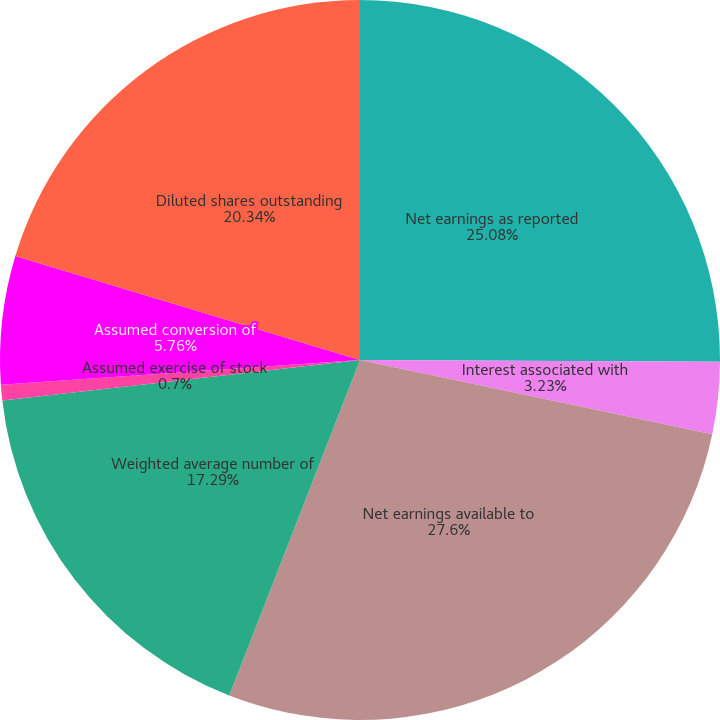Convert chart. <chart><loc_0><loc_0><loc_500><loc_500><pie_chart><fcel>Net earnings as reported<fcel>Interest associated with<fcel>Net earnings available to<fcel>Weighted average number of<fcel>Assumed exercise of stock<fcel>Assumed conversion of<fcel>Diluted shares outstanding<nl><fcel>25.08%<fcel>3.23%<fcel>27.61%<fcel>17.29%<fcel>0.7%<fcel>5.76%<fcel>20.34%<nl></chart> 